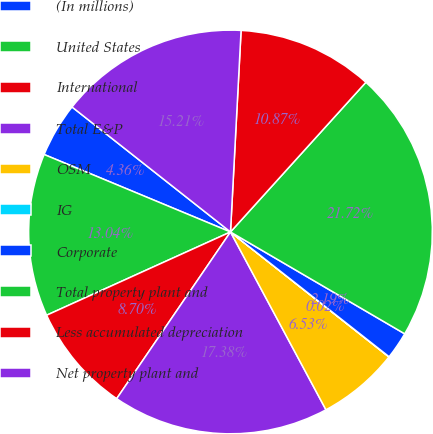<chart> <loc_0><loc_0><loc_500><loc_500><pie_chart><fcel>(In millions)<fcel>United States<fcel>International<fcel>Total E&P<fcel>OSM<fcel>IG<fcel>Corporate<fcel>Total property plant and<fcel>Less accumulated depreciation<fcel>Net property plant and<nl><fcel>4.36%<fcel>13.04%<fcel>8.7%<fcel>17.38%<fcel>6.53%<fcel>0.02%<fcel>2.19%<fcel>21.72%<fcel>10.87%<fcel>15.21%<nl></chart> 